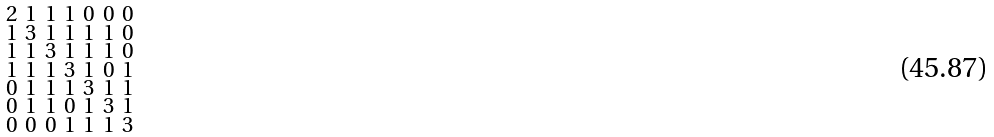Convert formula to latex. <formula><loc_0><loc_0><loc_500><loc_500>\begin{smallmatrix} 2 & 1 & 1 & 1 & 0 & 0 & 0 \\ 1 & 3 & 1 & 1 & 1 & 1 & 0 \\ 1 & 1 & 3 & 1 & 1 & 1 & 0 \\ 1 & 1 & 1 & 3 & 1 & 0 & 1 \\ 0 & 1 & 1 & 1 & 3 & 1 & 1 \\ 0 & 1 & 1 & 0 & 1 & 3 & 1 \\ 0 & 0 & 0 & 1 & 1 & 1 & 3 \end{smallmatrix}</formula> 